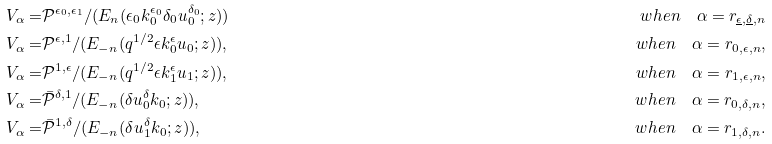Convert formula to latex. <formula><loc_0><loc_0><loc_500><loc_500>V _ { \alpha } = & \mathcal { P } ^ { \epsilon _ { 0 } , \epsilon _ { 1 } } / ( E _ { n } ( \epsilon _ { 0 } k _ { 0 } ^ { \epsilon _ { 0 } } \delta _ { 0 } u _ { 0 } ^ { \delta _ { 0 } } ; z ) ) \quad & w h e n \quad \alpha = r _ { \underline { \epsilon } , \underline { \delta } , n } \\ V _ { \alpha } = & \mathcal { P } ^ { \epsilon , 1 } / ( E _ { - n } ( q ^ { 1 / 2 } \epsilon k _ { 0 } ^ { \epsilon } u _ { 0 } ; z ) ) , \quad & w h e n \quad \alpha = r _ { 0 , \epsilon , n } , \\ V _ { \alpha } = & \mathcal { P } ^ { 1 , \epsilon } / ( E _ { - n } ( q ^ { 1 / 2 } \epsilon k _ { 1 } ^ { \epsilon } u _ { 1 } ; z ) ) , \quad & w h e n \quad \alpha = r _ { 1 , \epsilon , n } , \\ V _ { \alpha } = & \bar { \mathcal { P } } ^ { \delta , 1 } / ( E _ { - n } ( \delta u _ { 0 } ^ { \delta } k _ { 0 } ; z ) ) , \quad & w h e n \quad \alpha = r _ { 0 , \delta , n } , \\ V _ { \alpha } = & \bar { \mathcal { P } } ^ { 1 , \delta } / ( E _ { - n } ( \delta u _ { 1 } ^ { \delta } k _ { 0 } ; z ) ) , \quad & w h e n \quad \alpha = r _ { 1 , \delta , n } . \\</formula> 